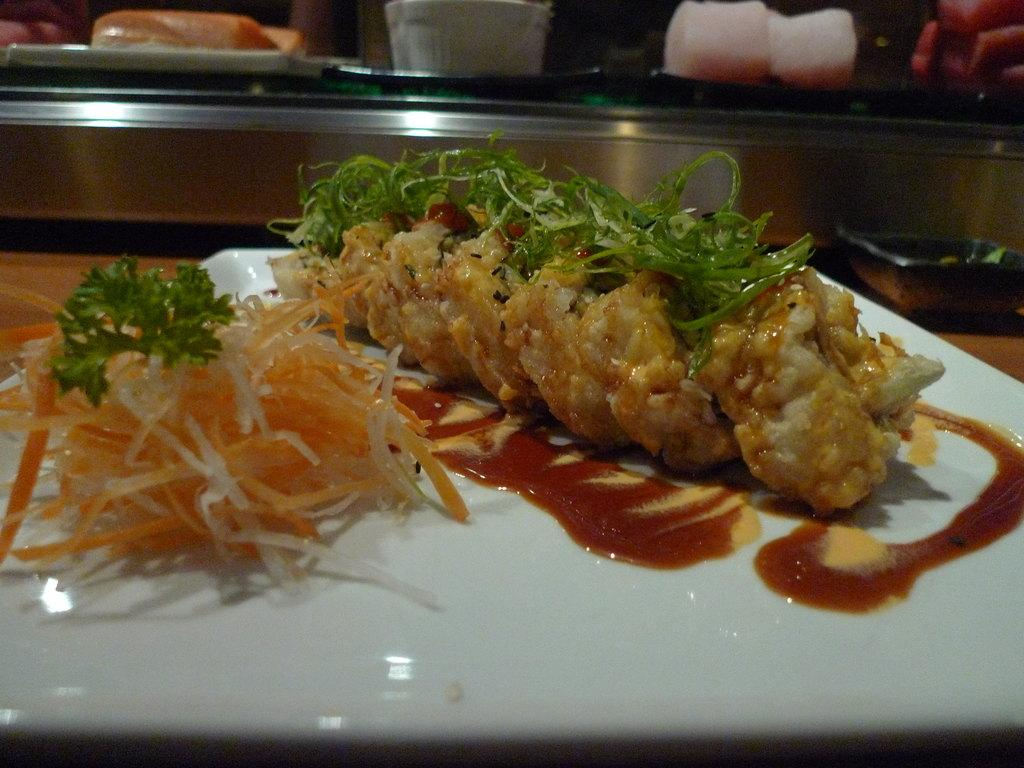What is on the white plate in the image? There is food on the plate. What is a specific ingredient or sauce on the food? Tomato sauce is on the food. What can be seen in the background of the image? There is an iron tray in the background. What type of garnish is on the food? Coriander leaves are on the food. Where is the father in the image? There is no father present in the image. Can you see a goldfish swimming in the food? No, there is no goldfish in the image. Is there a kettle visible on the iron tray in the background? The provided facts do not mention a kettle, so we cannot determine if one is present. 